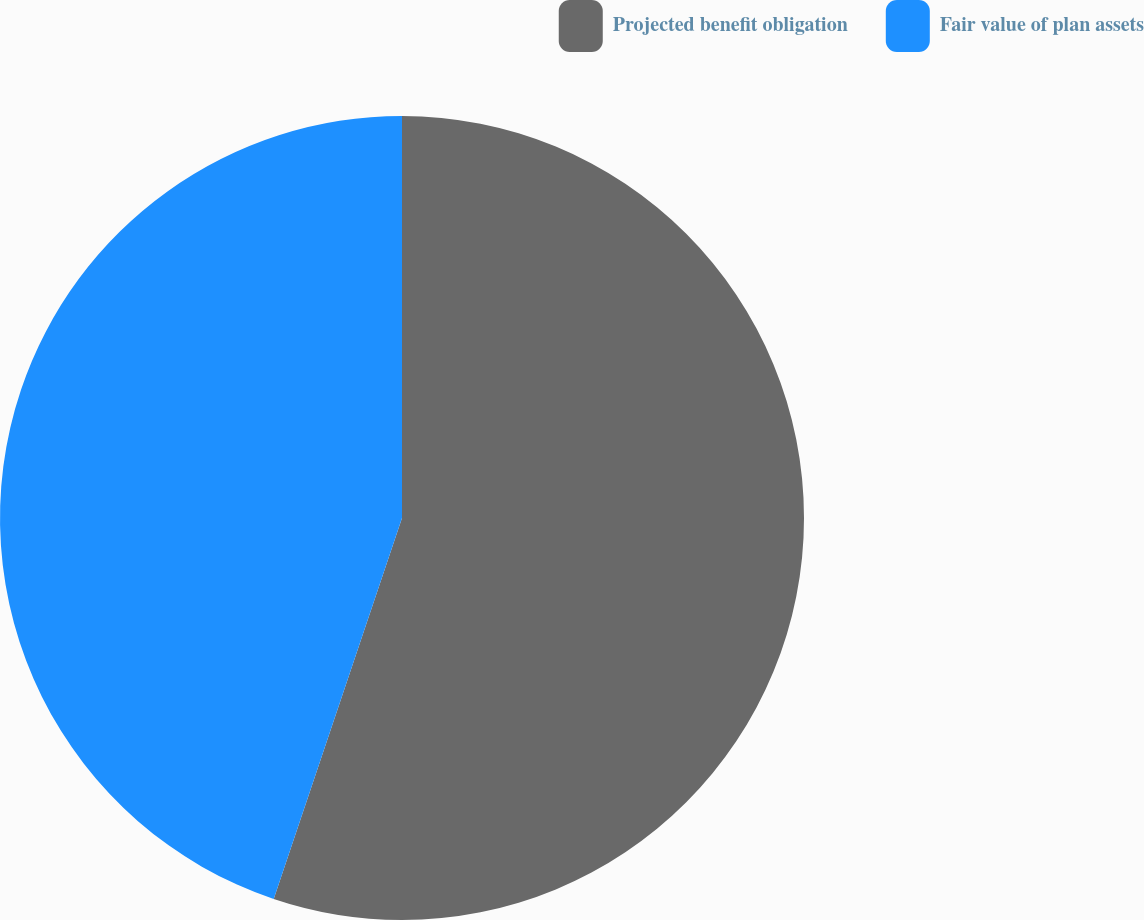Convert chart. <chart><loc_0><loc_0><loc_500><loc_500><pie_chart><fcel>Projected benefit obligation<fcel>Fair value of plan assets<nl><fcel>55.17%<fcel>44.83%<nl></chart> 